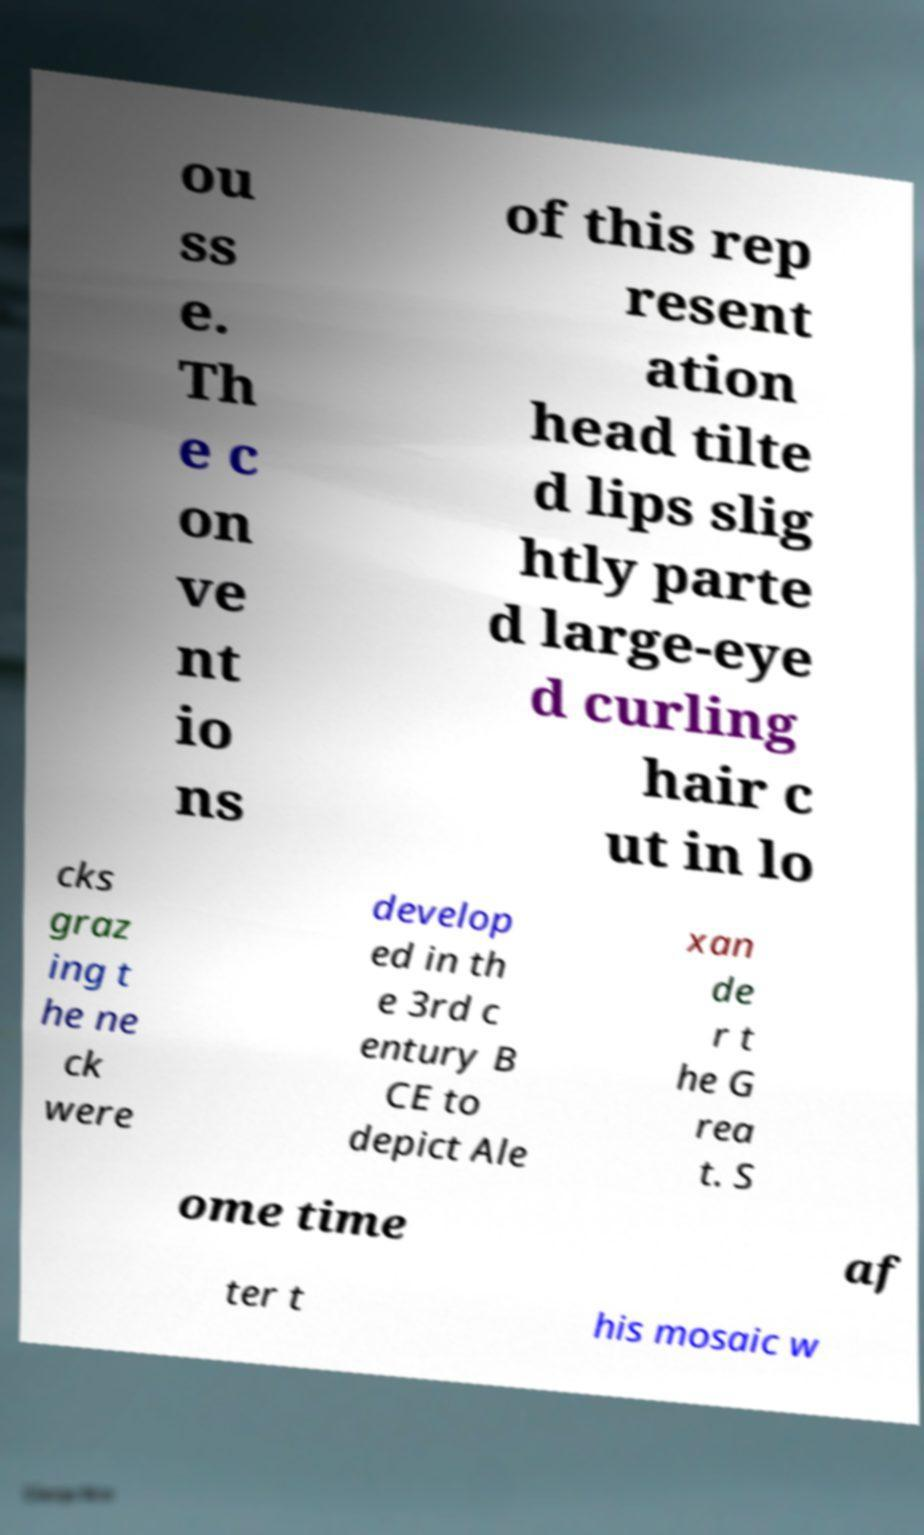For documentation purposes, I need the text within this image transcribed. Could you provide that? ou ss e. Th e c on ve nt io ns of this rep resent ation head tilte d lips slig htly parte d large-eye d curling hair c ut in lo cks graz ing t he ne ck were develop ed in th e 3rd c entury B CE to depict Ale xan de r t he G rea t. S ome time af ter t his mosaic w 